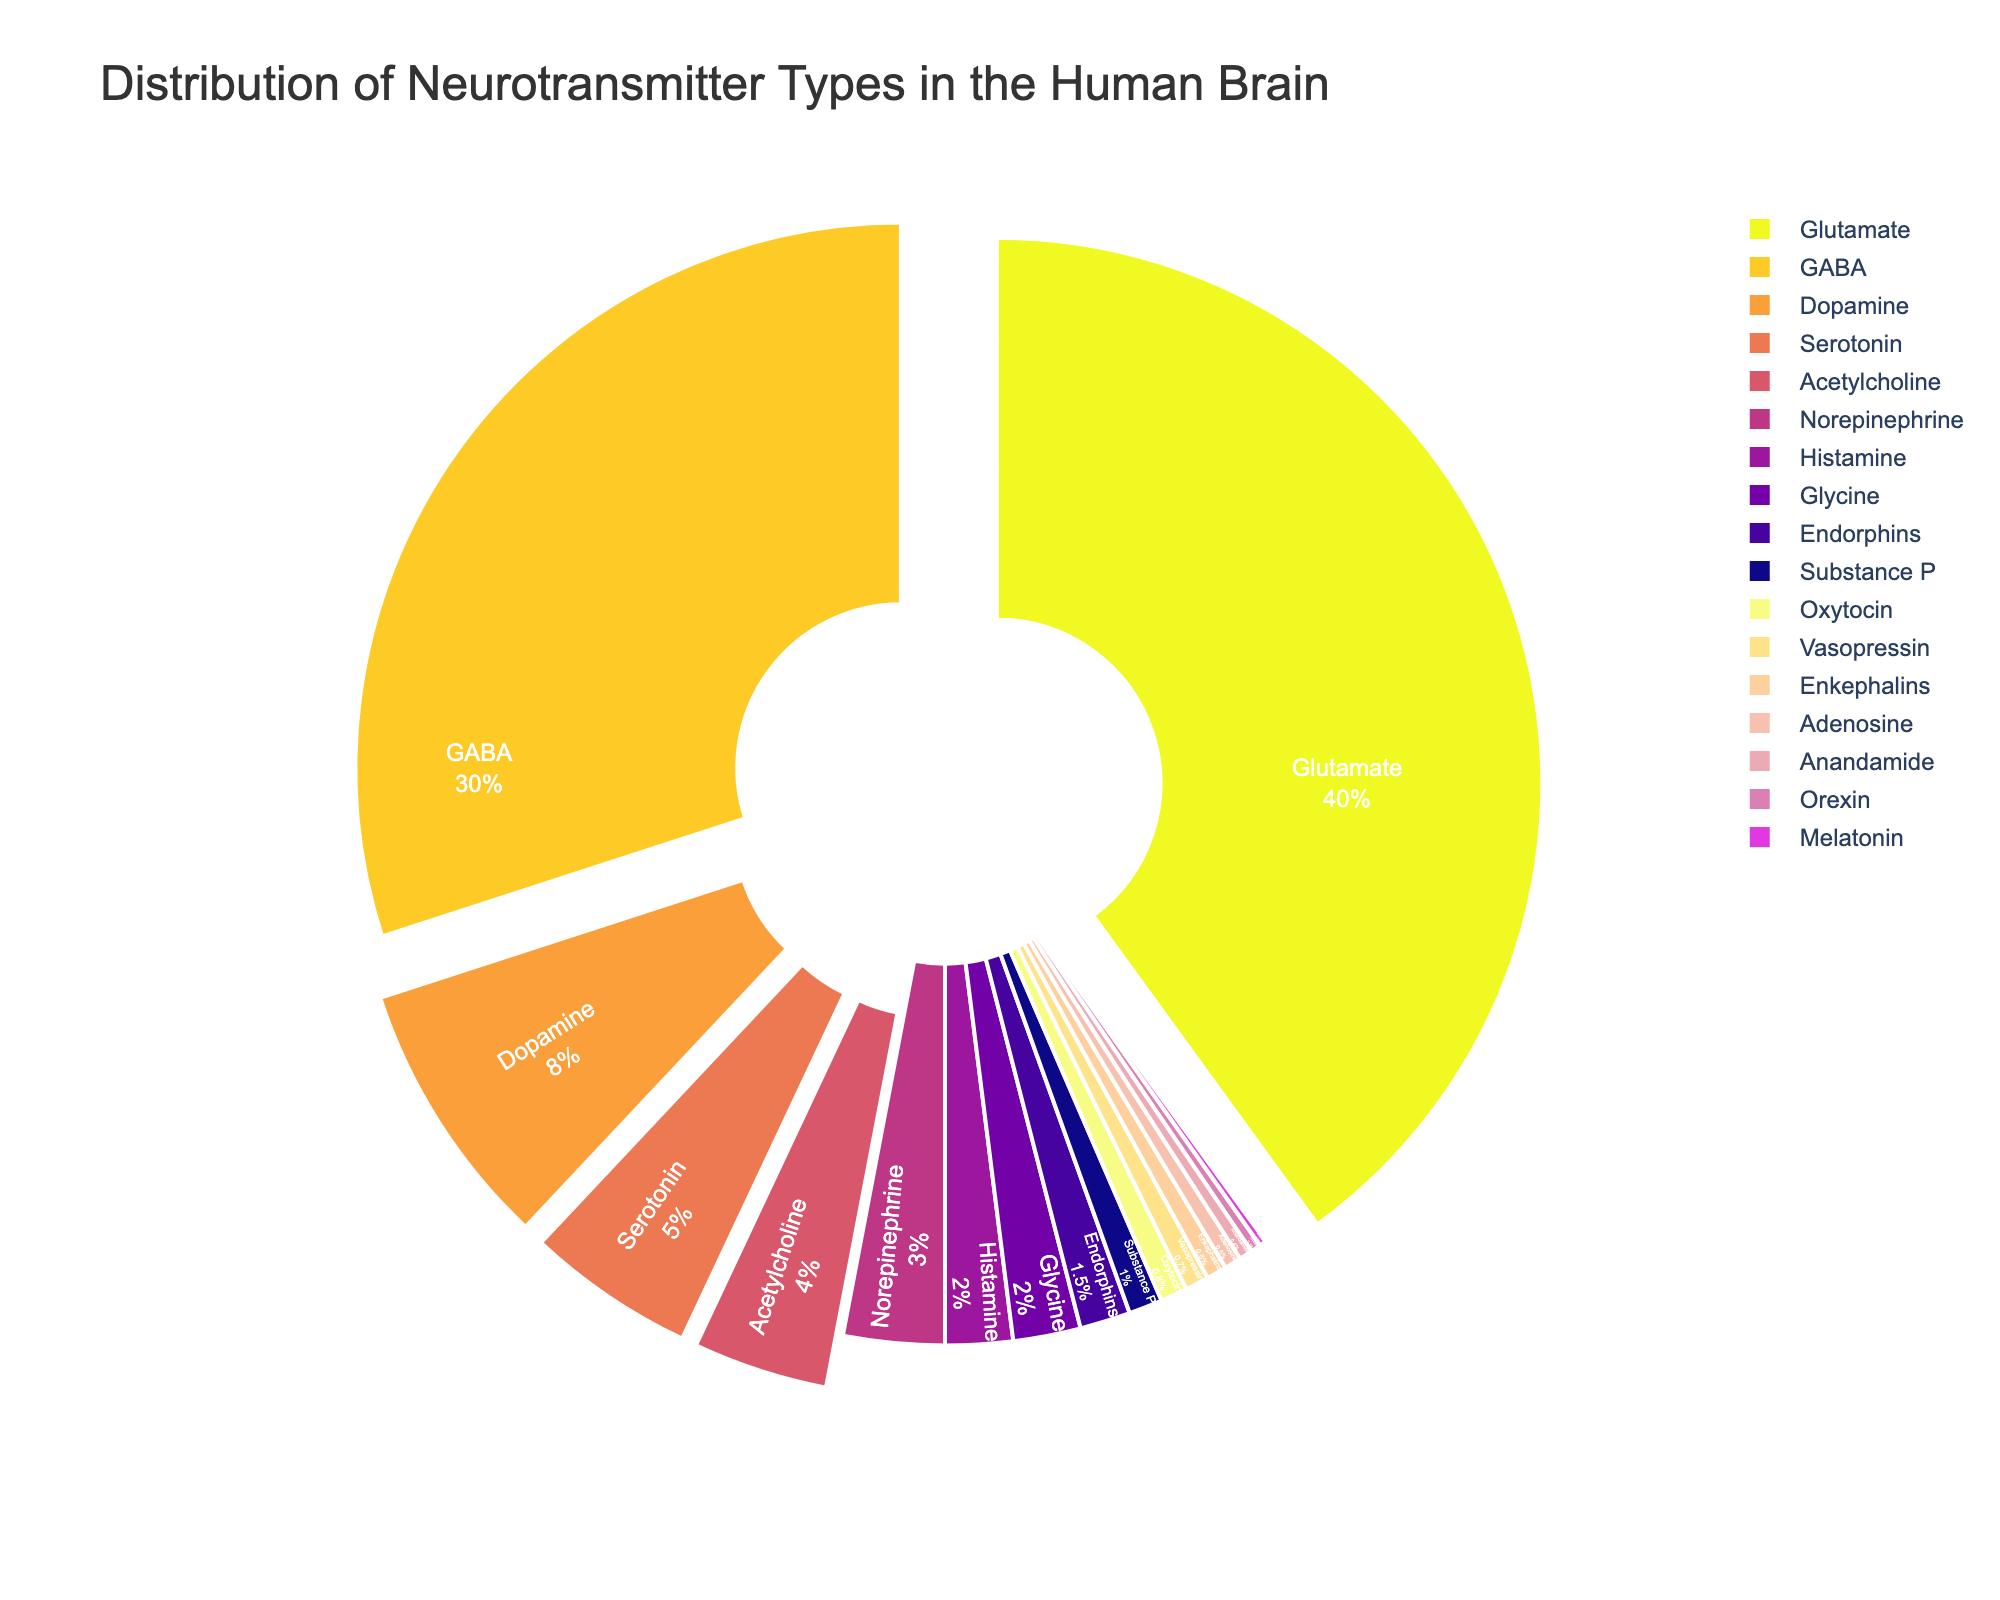Which neurotransmitter type constitutes the highest percentage? By looking at the pie chart, identify the segment with the largest proportion, labeled with the percentage value. Glutamate has the highest value at 40%.
Answer: Glutamate What is the combined percentage of Dopamine and Serotonin? Locate the segments labeled "Dopamine" and "Serotonin" and sum their percentage values. Dopamine is 8%, and Serotonin is 5%, so their combined percentage is 8% + 5% = 13%.
Answer: 13% How does the percentage of GABA compare to that of Norepinephrine? Compare the pie chart segments labeled "GABA" and "Norepinephrine". GABA is 30%, and Norepinephrine is 3%. 30% is significantly greater than 3%.
Answer: GABA has a higher percentage Which neurotransmitter type has the smallest percentage? Look for the smallest segment in the pie chart; it will be labeled with the percentage. The segment labeled "Melatonin" is the smallest at 0.2%.
Answer: Melatonin What is the total percentage for neurotransmitters that individually constitute less than 1%? Identify each neurotransmitter type with less than 1% and sum their percentages. These are Endorphins (1.5%), Substance P (1%), Oxytocin (0.8%), Vasopressin (0.7%), Enkephalins (0.6%), Adenosine (0.5%), Anandamide (0.4%), Orexin (0.3%), and Melatonin (0.2%). The total is 1.5% + 1% + 0.8% + 0.7% + 0.6% + 0.5% + 0.4% + 0.3% + 0.2% = 6%.
Answer: 6% How much larger is the percentage of Acetylcholine compared to that of Glycine? The pie chart shows Acetylcholine at 4% and Glycine at 2%. The difference is 4% - 2% = 2%.
Answer: 2% Identify the neurotransmitter types that have a percentage between 1% and 5%. Locate the segments with percentage values between 1% and 5%. These segments are Dopamine (8%), Serotonin (5%), Acetylcholine (4%), and Norepinephrine (3%)
Answer: Dopamine, Serotonin, Acetylcholine, Norepinephrine 